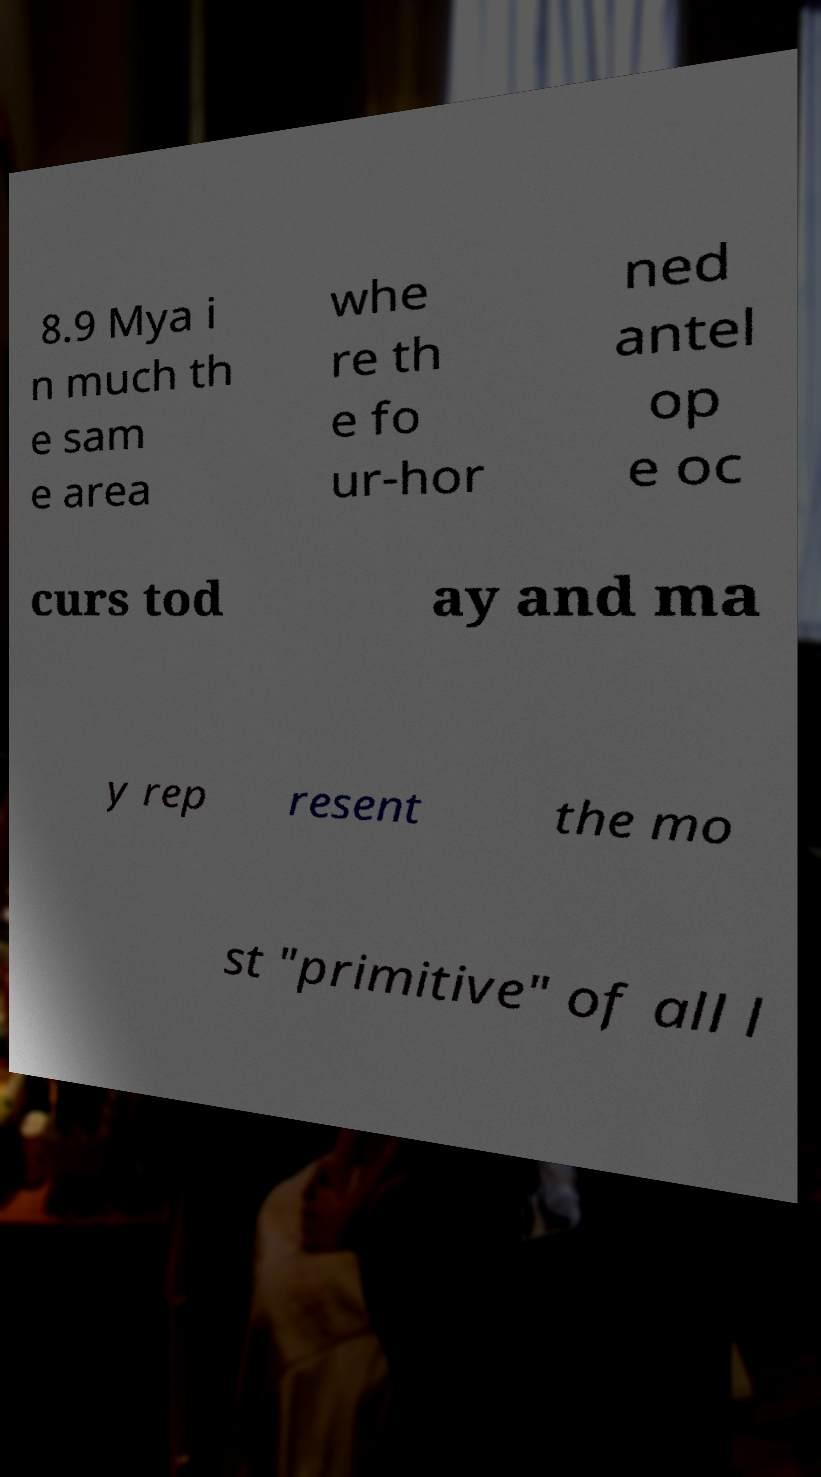What messages or text are displayed in this image? I need them in a readable, typed format. 8.9 Mya i n much th e sam e area whe re th e fo ur-hor ned antel op e oc curs tod ay and ma y rep resent the mo st "primitive" of all l 